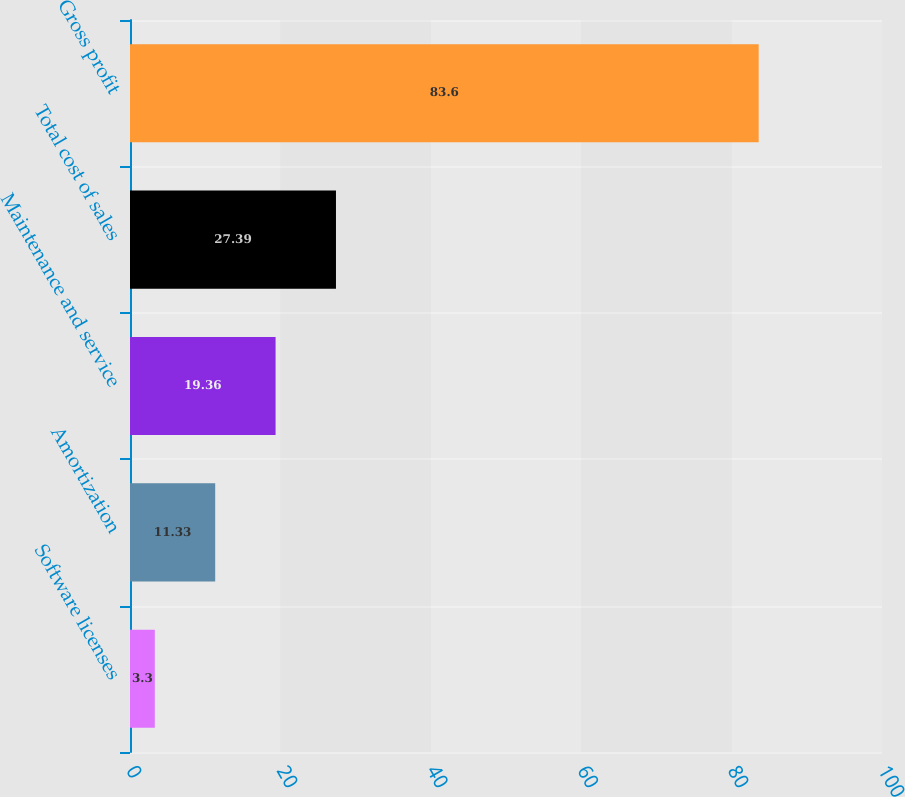Convert chart. <chart><loc_0><loc_0><loc_500><loc_500><bar_chart><fcel>Software licenses<fcel>Amortization<fcel>Maintenance and service<fcel>Total cost of sales<fcel>Gross profit<nl><fcel>3.3<fcel>11.33<fcel>19.36<fcel>27.39<fcel>83.6<nl></chart> 